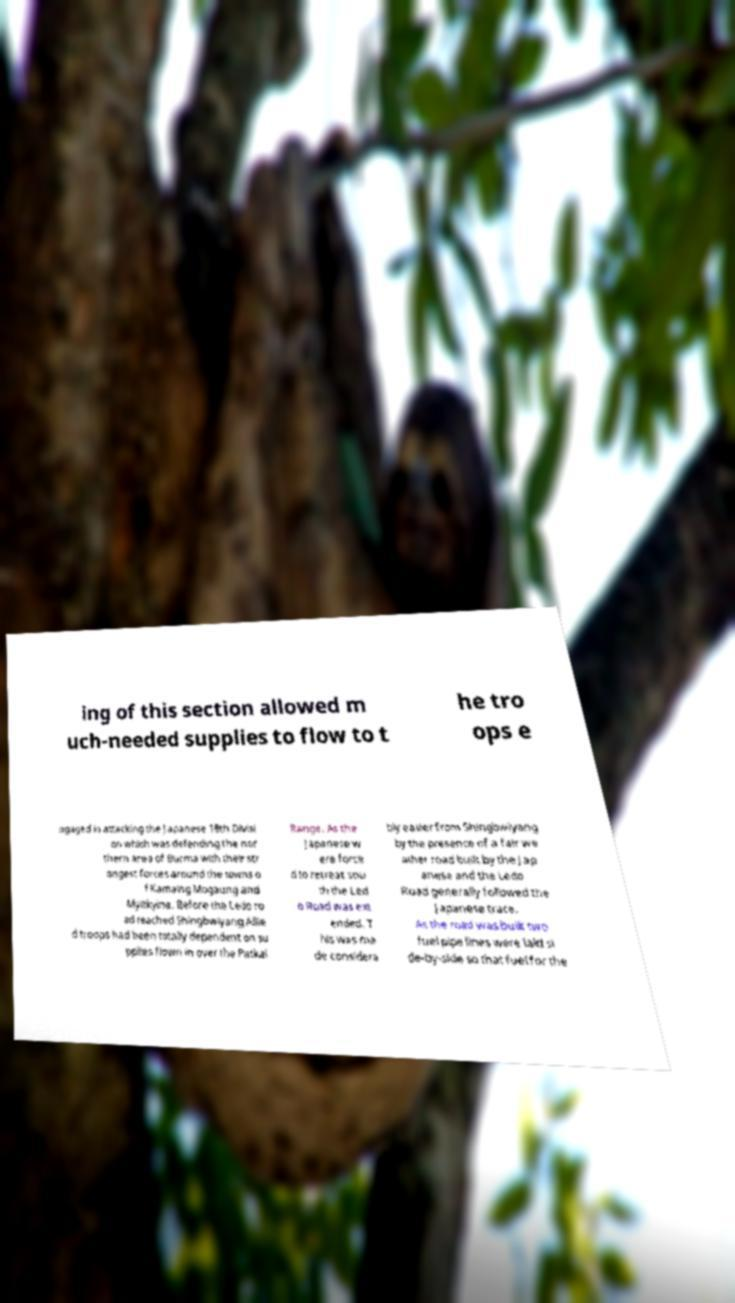Could you extract and type out the text from this image? ing of this section allowed m uch-needed supplies to flow to t he tro ops e ngaged in attacking the Japanese 18th Divisi on which was defending the nor thern area of Burma with their str ongest forces around the towns o f Kamaing Mogaung and Myitkyina. Before the Ledo ro ad reached Shingbwiyang Allie d troops had been totally dependent on su pplies flown in over the Patkai Range. As the Japanese w ere force d to retreat sou th the Led o Road was ext ended. T his was ma de considera bly easier from Shingbwiyang by the presence of a fair we ather road built by the Jap anese and the Ledo Road generally followed the Japanese trace. As the road was built two fuel pipe lines were laid si de-by-side so that fuel for the 